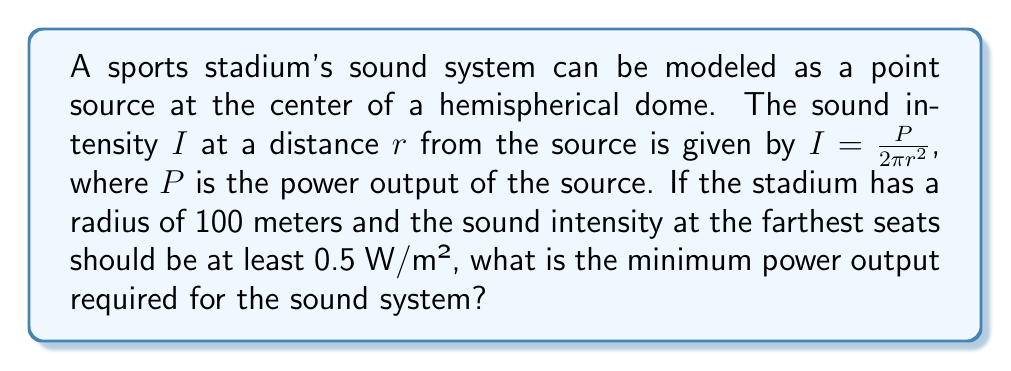Could you help me with this problem? To solve this problem, we'll follow these steps:

1) We're given the formula for sound intensity:
   $$I = \frac{P}{2\pi r^2}$$

2) We know:
   - $r$ (radius of the stadium) = 100 meters
   - $I$ (minimum intensity at the farthest seats) = 0.5 W/m²

3) We need to solve for $P$. Let's rearrange the formula:
   $$P = I \cdot 2\pi r^2$$

4) Now, let's substitute the known values:
   $$P = 0.5 \text{ W/m²} \cdot 2\pi \cdot (100 \text{ m})^2$$

5) Calculate:
   $$P = 0.5 \cdot 2\pi \cdot 10000 \text{ W}$$
   $$P = \pi \cdot 10000 \text{ W}$$
   $$P = 31415.93 \text{ W}$$

6) Round to the nearest whole number:
   $$P \approx 31416 \text{ W}$$

Therefore, the minimum power output required for the sound system is approximately 31416 watts or 31.416 kilowatts.
Answer: 31416 W 